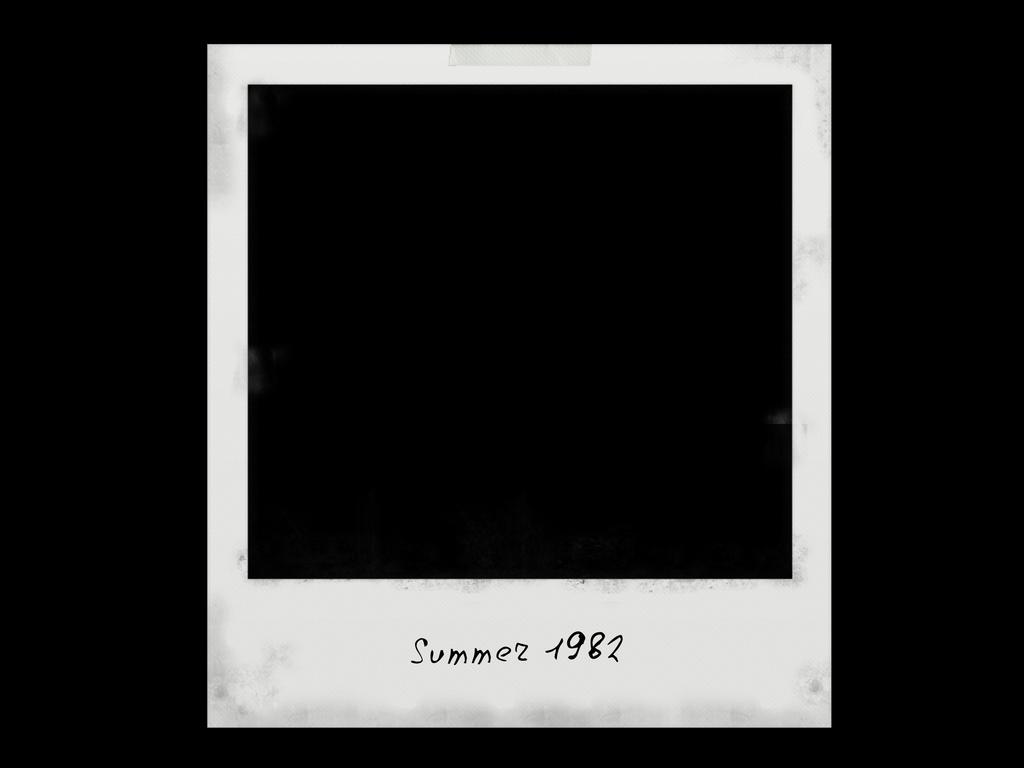What season is shown on this photo?
Your response must be concise. Summer. What season was the photo taken during?
Give a very brief answer. Summer. 